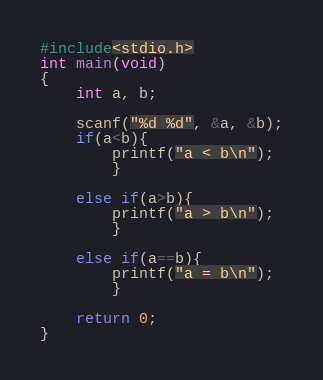<code> <loc_0><loc_0><loc_500><loc_500><_C_>#include<stdio.h>
int main(void)
{
    int a, b;
    
    scanf("%d %d", &a, &b);
    if(a<b){
        printf("a < b\n");
        }
    
    else if(a>b){
        printf("a > b\n");
        }
    
    else if(a==b){
        printf("a = b\n");
        }
    
    return 0;
}</code> 